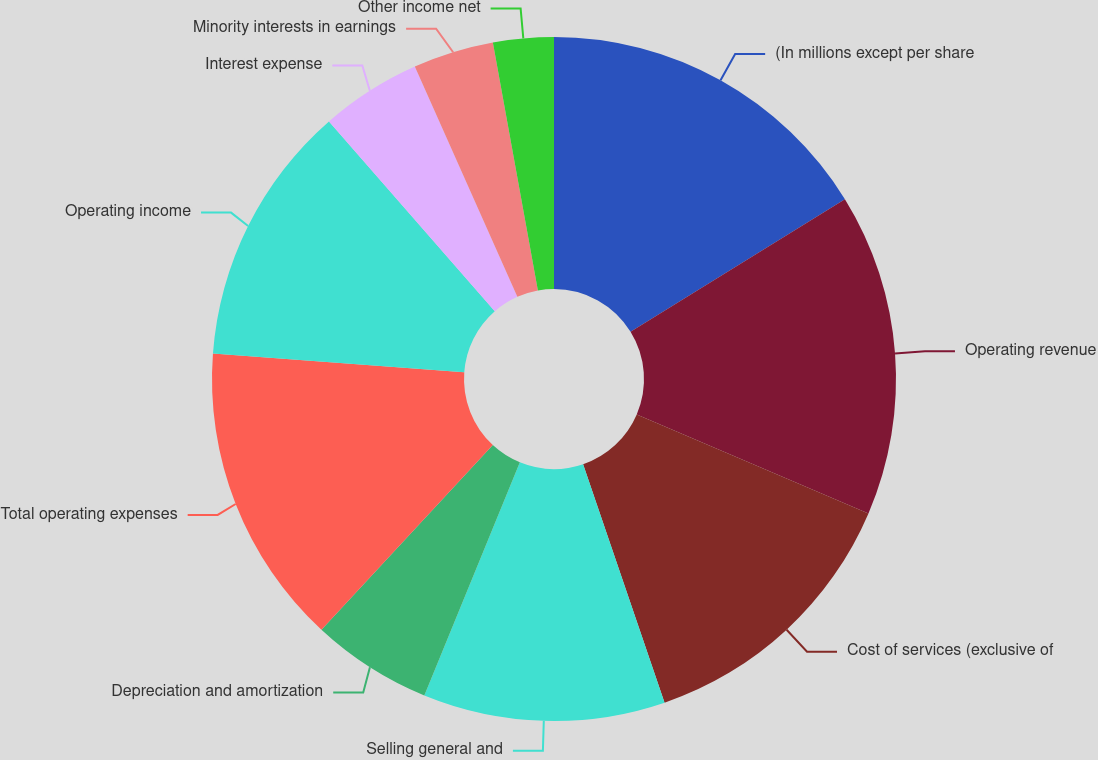Convert chart to OTSL. <chart><loc_0><loc_0><loc_500><loc_500><pie_chart><fcel>(In millions except per share<fcel>Operating revenue<fcel>Cost of services (exclusive of<fcel>Selling general and<fcel>Depreciation and amortization<fcel>Total operating expenses<fcel>Operating income<fcel>Interest expense<fcel>Minority interests in earnings<fcel>Other income net<nl><fcel>16.19%<fcel>15.24%<fcel>13.33%<fcel>11.43%<fcel>5.71%<fcel>14.29%<fcel>12.38%<fcel>4.76%<fcel>3.81%<fcel>2.86%<nl></chart> 